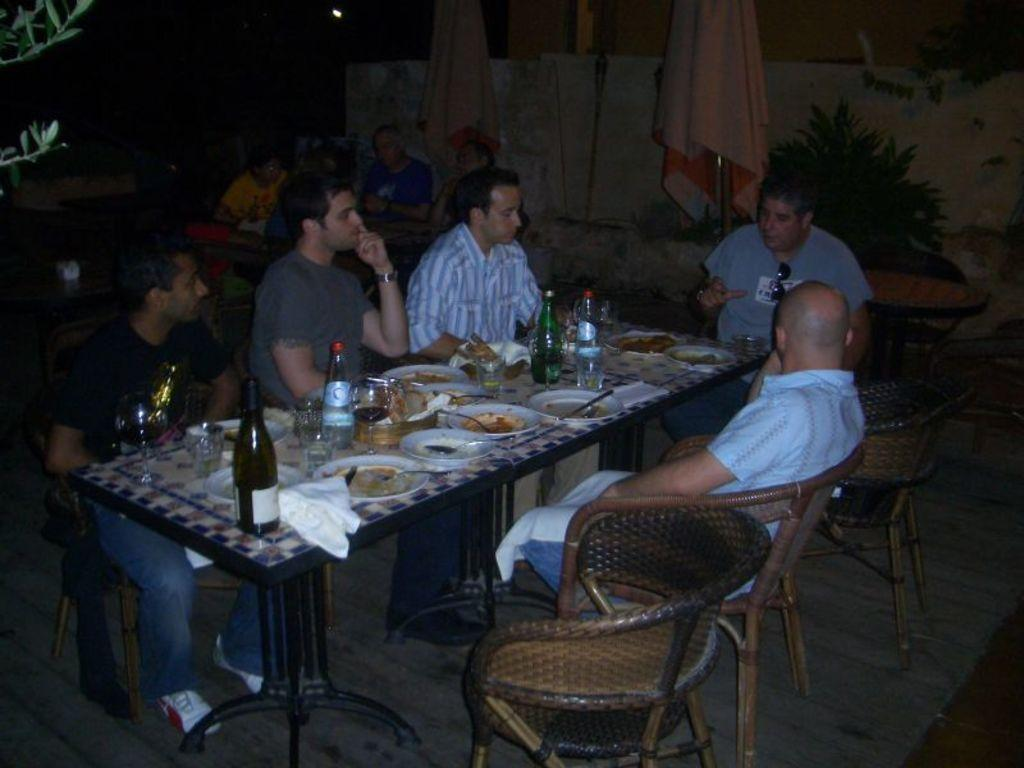How many people are in the image? There is a group of people in the image. What are the people doing in the image? The people are sitting on chairs. What is in front of the people? There is a table in front of the people. What is on the table? The table has food on it and a bottle of wine. What type of education can be seen on the table in the image? There is no education present in the image; it features a table with food and a bottle of wine. What type of polish is being used on the chairs in the image? There is no mention of polish or any specific treatment of the chairs in the image. 